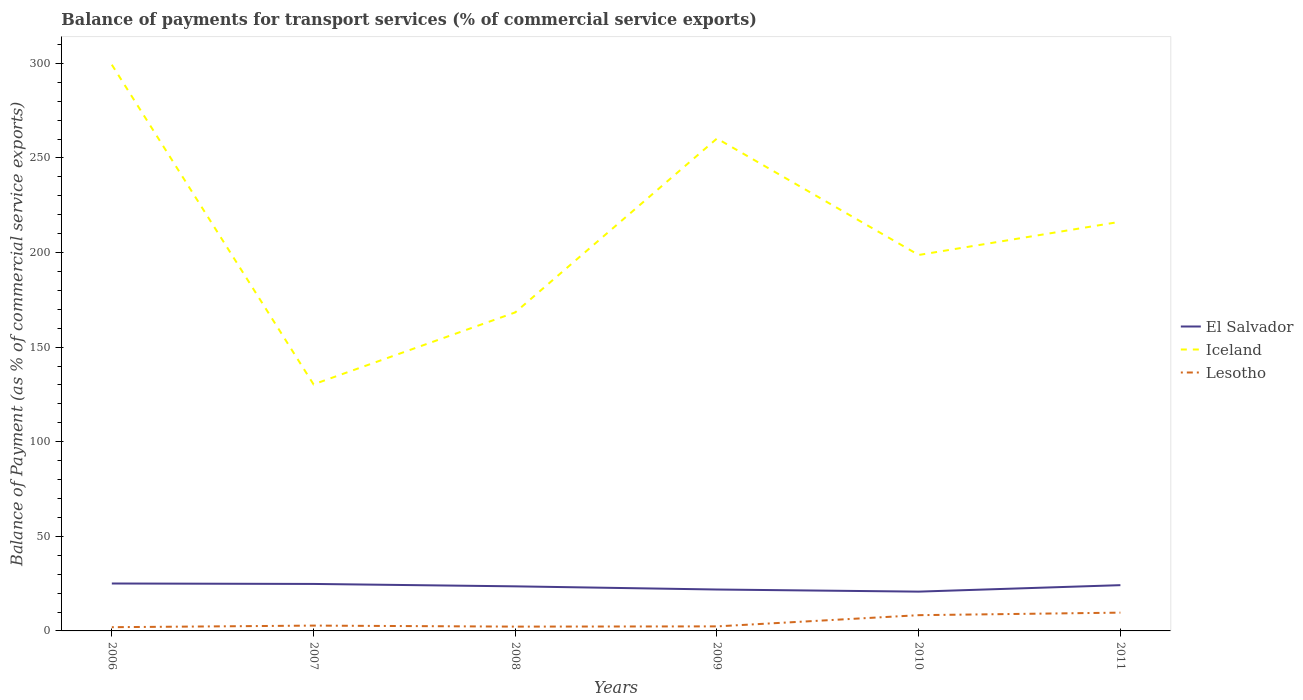Does the line corresponding to Iceland intersect with the line corresponding to Lesotho?
Make the answer very short. No. Across all years, what is the maximum balance of payments for transport services in Lesotho?
Your answer should be compact. 1.97. In which year was the balance of payments for transport services in Lesotho maximum?
Ensure brevity in your answer.  2006. What is the total balance of payments for transport services in El Salvador in the graph?
Keep it short and to the point. 1.27. What is the difference between the highest and the second highest balance of payments for transport services in El Salvador?
Ensure brevity in your answer.  4.3. What is the difference between the highest and the lowest balance of payments for transport services in El Salvador?
Offer a terse response. 4. What is the difference between two consecutive major ticks on the Y-axis?
Keep it short and to the point. 50. Does the graph contain any zero values?
Give a very brief answer. No. Where does the legend appear in the graph?
Your answer should be compact. Center right. How are the legend labels stacked?
Your response must be concise. Vertical. What is the title of the graph?
Your answer should be compact. Balance of payments for transport services (% of commercial service exports). What is the label or title of the X-axis?
Offer a terse response. Years. What is the label or title of the Y-axis?
Your answer should be compact. Balance of Payment (as % of commercial service exports). What is the Balance of Payment (as % of commercial service exports) of El Salvador in 2006?
Ensure brevity in your answer.  25.07. What is the Balance of Payment (as % of commercial service exports) in Iceland in 2006?
Ensure brevity in your answer.  299.28. What is the Balance of Payment (as % of commercial service exports) of Lesotho in 2006?
Your answer should be compact. 1.97. What is the Balance of Payment (as % of commercial service exports) in El Salvador in 2007?
Offer a very short reply. 24.84. What is the Balance of Payment (as % of commercial service exports) in Iceland in 2007?
Offer a terse response. 130.32. What is the Balance of Payment (as % of commercial service exports) in Lesotho in 2007?
Provide a short and direct response. 2.81. What is the Balance of Payment (as % of commercial service exports) of El Salvador in 2008?
Your response must be concise. 23.56. What is the Balance of Payment (as % of commercial service exports) of Iceland in 2008?
Give a very brief answer. 168.36. What is the Balance of Payment (as % of commercial service exports) of Lesotho in 2008?
Provide a short and direct response. 2.27. What is the Balance of Payment (as % of commercial service exports) of El Salvador in 2009?
Provide a succinct answer. 21.88. What is the Balance of Payment (as % of commercial service exports) of Iceland in 2009?
Your answer should be very brief. 260.27. What is the Balance of Payment (as % of commercial service exports) in Lesotho in 2009?
Your response must be concise. 2.4. What is the Balance of Payment (as % of commercial service exports) of El Salvador in 2010?
Offer a terse response. 20.77. What is the Balance of Payment (as % of commercial service exports) of Iceland in 2010?
Your answer should be very brief. 198.71. What is the Balance of Payment (as % of commercial service exports) in Lesotho in 2010?
Your answer should be very brief. 8.32. What is the Balance of Payment (as % of commercial service exports) in El Salvador in 2011?
Your answer should be very brief. 24.19. What is the Balance of Payment (as % of commercial service exports) in Iceland in 2011?
Offer a terse response. 216.28. What is the Balance of Payment (as % of commercial service exports) in Lesotho in 2011?
Make the answer very short. 9.67. Across all years, what is the maximum Balance of Payment (as % of commercial service exports) of El Salvador?
Ensure brevity in your answer.  25.07. Across all years, what is the maximum Balance of Payment (as % of commercial service exports) of Iceland?
Make the answer very short. 299.28. Across all years, what is the maximum Balance of Payment (as % of commercial service exports) of Lesotho?
Keep it short and to the point. 9.67. Across all years, what is the minimum Balance of Payment (as % of commercial service exports) in El Salvador?
Make the answer very short. 20.77. Across all years, what is the minimum Balance of Payment (as % of commercial service exports) of Iceland?
Your answer should be compact. 130.32. Across all years, what is the minimum Balance of Payment (as % of commercial service exports) of Lesotho?
Make the answer very short. 1.97. What is the total Balance of Payment (as % of commercial service exports) of El Salvador in the graph?
Your answer should be very brief. 140.31. What is the total Balance of Payment (as % of commercial service exports) in Iceland in the graph?
Give a very brief answer. 1273.22. What is the total Balance of Payment (as % of commercial service exports) in Lesotho in the graph?
Provide a short and direct response. 27.45. What is the difference between the Balance of Payment (as % of commercial service exports) of El Salvador in 2006 and that in 2007?
Offer a terse response. 0.23. What is the difference between the Balance of Payment (as % of commercial service exports) of Iceland in 2006 and that in 2007?
Ensure brevity in your answer.  168.95. What is the difference between the Balance of Payment (as % of commercial service exports) in Lesotho in 2006 and that in 2007?
Provide a short and direct response. -0.84. What is the difference between the Balance of Payment (as % of commercial service exports) of El Salvador in 2006 and that in 2008?
Offer a very short reply. 1.51. What is the difference between the Balance of Payment (as % of commercial service exports) of Iceland in 2006 and that in 2008?
Offer a terse response. 130.92. What is the difference between the Balance of Payment (as % of commercial service exports) in Lesotho in 2006 and that in 2008?
Your response must be concise. -0.31. What is the difference between the Balance of Payment (as % of commercial service exports) in El Salvador in 2006 and that in 2009?
Your response must be concise. 3.18. What is the difference between the Balance of Payment (as % of commercial service exports) of Iceland in 2006 and that in 2009?
Provide a short and direct response. 39.01. What is the difference between the Balance of Payment (as % of commercial service exports) in Lesotho in 2006 and that in 2009?
Provide a short and direct response. -0.43. What is the difference between the Balance of Payment (as % of commercial service exports) of El Salvador in 2006 and that in 2010?
Make the answer very short. 4.3. What is the difference between the Balance of Payment (as % of commercial service exports) in Iceland in 2006 and that in 2010?
Keep it short and to the point. 100.57. What is the difference between the Balance of Payment (as % of commercial service exports) in Lesotho in 2006 and that in 2010?
Provide a short and direct response. -6.35. What is the difference between the Balance of Payment (as % of commercial service exports) of El Salvador in 2006 and that in 2011?
Ensure brevity in your answer.  0.88. What is the difference between the Balance of Payment (as % of commercial service exports) of Iceland in 2006 and that in 2011?
Your response must be concise. 83. What is the difference between the Balance of Payment (as % of commercial service exports) of Lesotho in 2006 and that in 2011?
Your response must be concise. -7.7. What is the difference between the Balance of Payment (as % of commercial service exports) of El Salvador in 2007 and that in 2008?
Ensure brevity in your answer.  1.27. What is the difference between the Balance of Payment (as % of commercial service exports) of Iceland in 2007 and that in 2008?
Your answer should be very brief. -38.04. What is the difference between the Balance of Payment (as % of commercial service exports) of Lesotho in 2007 and that in 2008?
Keep it short and to the point. 0.54. What is the difference between the Balance of Payment (as % of commercial service exports) of El Salvador in 2007 and that in 2009?
Your answer should be compact. 2.95. What is the difference between the Balance of Payment (as % of commercial service exports) in Iceland in 2007 and that in 2009?
Make the answer very short. -129.95. What is the difference between the Balance of Payment (as % of commercial service exports) in Lesotho in 2007 and that in 2009?
Give a very brief answer. 0.41. What is the difference between the Balance of Payment (as % of commercial service exports) in El Salvador in 2007 and that in 2010?
Offer a very short reply. 4.07. What is the difference between the Balance of Payment (as % of commercial service exports) of Iceland in 2007 and that in 2010?
Your answer should be very brief. -68.38. What is the difference between the Balance of Payment (as % of commercial service exports) in Lesotho in 2007 and that in 2010?
Your answer should be very brief. -5.51. What is the difference between the Balance of Payment (as % of commercial service exports) of El Salvador in 2007 and that in 2011?
Your answer should be very brief. 0.65. What is the difference between the Balance of Payment (as % of commercial service exports) in Iceland in 2007 and that in 2011?
Ensure brevity in your answer.  -85.96. What is the difference between the Balance of Payment (as % of commercial service exports) in Lesotho in 2007 and that in 2011?
Keep it short and to the point. -6.85. What is the difference between the Balance of Payment (as % of commercial service exports) in El Salvador in 2008 and that in 2009?
Provide a succinct answer. 1.68. What is the difference between the Balance of Payment (as % of commercial service exports) of Iceland in 2008 and that in 2009?
Offer a very short reply. -91.91. What is the difference between the Balance of Payment (as % of commercial service exports) of Lesotho in 2008 and that in 2009?
Your answer should be very brief. -0.13. What is the difference between the Balance of Payment (as % of commercial service exports) of El Salvador in 2008 and that in 2010?
Keep it short and to the point. 2.79. What is the difference between the Balance of Payment (as % of commercial service exports) in Iceland in 2008 and that in 2010?
Your response must be concise. -30.35. What is the difference between the Balance of Payment (as % of commercial service exports) in Lesotho in 2008 and that in 2010?
Make the answer very short. -6.05. What is the difference between the Balance of Payment (as % of commercial service exports) in El Salvador in 2008 and that in 2011?
Offer a terse response. -0.63. What is the difference between the Balance of Payment (as % of commercial service exports) in Iceland in 2008 and that in 2011?
Ensure brevity in your answer.  -47.92. What is the difference between the Balance of Payment (as % of commercial service exports) of Lesotho in 2008 and that in 2011?
Make the answer very short. -7.39. What is the difference between the Balance of Payment (as % of commercial service exports) of El Salvador in 2009 and that in 2010?
Make the answer very short. 1.12. What is the difference between the Balance of Payment (as % of commercial service exports) of Iceland in 2009 and that in 2010?
Ensure brevity in your answer.  61.56. What is the difference between the Balance of Payment (as % of commercial service exports) of Lesotho in 2009 and that in 2010?
Make the answer very short. -5.92. What is the difference between the Balance of Payment (as % of commercial service exports) of El Salvador in 2009 and that in 2011?
Offer a very short reply. -2.31. What is the difference between the Balance of Payment (as % of commercial service exports) of Iceland in 2009 and that in 2011?
Provide a succinct answer. 43.99. What is the difference between the Balance of Payment (as % of commercial service exports) of Lesotho in 2009 and that in 2011?
Your response must be concise. -7.26. What is the difference between the Balance of Payment (as % of commercial service exports) of El Salvador in 2010 and that in 2011?
Provide a succinct answer. -3.42. What is the difference between the Balance of Payment (as % of commercial service exports) of Iceland in 2010 and that in 2011?
Ensure brevity in your answer.  -17.57. What is the difference between the Balance of Payment (as % of commercial service exports) of Lesotho in 2010 and that in 2011?
Ensure brevity in your answer.  -1.34. What is the difference between the Balance of Payment (as % of commercial service exports) of El Salvador in 2006 and the Balance of Payment (as % of commercial service exports) of Iceland in 2007?
Your answer should be compact. -105.25. What is the difference between the Balance of Payment (as % of commercial service exports) of El Salvador in 2006 and the Balance of Payment (as % of commercial service exports) of Lesotho in 2007?
Your answer should be very brief. 22.26. What is the difference between the Balance of Payment (as % of commercial service exports) in Iceland in 2006 and the Balance of Payment (as % of commercial service exports) in Lesotho in 2007?
Offer a terse response. 296.46. What is the difference between the Balance of Payment (as % of commercial service exports) of El Salvador in 2006 and the Balance of Payment (as % of commercial service exports) of Iceland in 2008?
Make the answer very short. -143.29. What is the difference between the Balance of Payment (as % of commercial service exports) of El Salvador in 2006 and the Balance of Payment (as % of commercial service exports) of Lesotho in 2008?
Keep it short and to the point. 22.79. What is the difference between the Balance of Payment (as % of commercial service exports) in Iceland in 2006 and the Balance of Payment (as % of commercial service exports) in Lesotho in 2008?
Keep it short and to the point. 297. What is the difference between the Balance of Payment (as % of commercial service exports) in El Salvador in 2006 and the Balance of Payment (as % of commercial service exports) in Iceland in 2009?
Your response must be concise. -235.2. What is the difference between the Balance of Payment (as % of commercial service exports) in El Salvador in 2006 and the Balance of Payment (as % of commercial service exports) in Lesotho in 2009?
Your answer should be compact. 22.67. What is the difference between the Balance of Payment (as % of commercial service exports) of Iceland in 2006 and the Balance of Payment (as % of commercial service exports) of Lesotho in 2009?
Offer a terse response. 296.87. What is the difference between the Balance of Payment (as % of commercial service exports) of El Salvador in 2006 and the Balance of Payment (as % of commercial service exports) of Iceland in 2010?
Offer a terse response. -173.64. What is the difference between the Balance of Payment (as % of commercial service exports) of El Salvador in 2006 and the Balance of Payment (as % of commercial service exports) of Lesotho in 2010?
Provide a succinct answer. 16.75. What is the difference between the Balance of Payment (as % of commercial service exports) in Iceland in 2006 and the Balance of Payment (as % of commercial service exports) in Lesotho in 2010?
Provide a short and direct response. 290.95. What is the difference between the Balance of Payment (as % of commercial service exports) in El Salvador in 2006 and the Balance of Payment (as % of commercial service exports) in Iceland in 2011?
Offer a terse response. -191.21. What is the difference between the Balance of Payment (as % of commercial service exports) in El Salvador in 2006 and the Balance of Payment (as % of commercial service exports) in Lesotho in 2011?
Your answer should be compact. 15.4. What is the difference between the Balance of Payment (as % of commercial service exports) in Iceland in 2006 and the Balance of Payment (as % of commercial service exports) in Lesotho in 2011?
Give a very brief answer. 289.61. What is the difference between the Balance of Payment (as % of commercial service exports) in El Salvador in 2007 and the Balance of Payment (as % of commercial service exports) in Iceland in 2008?
Keep it short and to the point. -143.52. What is the difference between the Balance of Payment (as % of commercial service exports) in El Salvador in 2007 and the Balance of Payment (as % of commercial service exports) in Lesotho in 2008?
Provide a succinct answer. 22.56. What is the difference between the Balance of Payment (as % of commercial service exports) of Iceland in 2007 and the Balance of Payment (as % of commercial service exports) of Lesotho in 2008?
Make the answer very short. 128.05. What is the difference between the Balance of Payment (as % of commercial service exports) of El Salvador in 2007 and the Balance of Payment (as % of commercial service exports) of Iceland in 2009?
Offer a terse response. -235.43. What is the difference between the Balance of Payment (as % of commercial service exports) in El Salvador in 2007 and the Balance of Payment (as % of commercial service exports) in Lesotho in 2009?
Your answer should be compact. 22.43. What is the difference between the Balance of Payment (as % of commercial service exports) of Iceland in 2007 and the Balance of Payment (as % of commercial service exports) of Lesotho in 2009?
Offer a very short reply. 127.92. What is the difference between the Balance of Payment (as % of commercial service exports) in El Salvador in 2007 and the Balance of Payment (as % of commercial service exports) in Iceland in 2010?
Give a very brief answer. -173.87. What is the difference between the Balance of Payment (as % of commercial service exports) in El Salvador in 2007 and the Balance of Payment (as % of commercial service exports) in Lesotho in 2010?
Offer a terse response. 16.51. What is the difference between the Balance of Payment (as % of commercial service exports) of Iceland in 2007 and the Balance of Payment (as % of commercial service exports) of Lesotho in 2010?
Provide a short and direct response. 122. What is the difference between the Balance of Payment (as % of commercial service exports) in El Salvador in 2007 and the Balance of Payment (as % of commercial service exports) in Iceland in 2011?
Your answer should be very brief. -191.44. What is the difference between the Balance of Payment (as % of commercial service exports) of El Salvador in 2007 and the Balance of Payment (as % of commercial service exports) of Lesotho in 2011?
Provide a succinct answer. 15.17. What is the difference between the Balance of Payment (as % of commercial service exports) of Iceland in 2007 and the Balance of Payment (as % of commercial service exports) of Lesotho in 2011?
Give a very brief answer. 120.66. What is the difference between the Balance of Payment (as % of commercial service exports) of El Salvador in 2008 and the Balance of Payment (as % of commercial service exports) of Iceland in 2009?
Offer a very short reply. -236.71. What is the difference between the Balance of Payment (as % of commercial service exports) of El Salvador in 2008 and the Balance of Payment (as % of commercial service exports) of Lesotho in 2009?
Make the answer very short. 21.16. What is the difference between the Balance of Payment (as % of commercial service exports) in Iceland in 2008 and the Balance of Payment (as % of commercial service exports) in Lesotho in 2009?
Your answer should be compact. 165.96. What is the difference between the Balance of Payment (as % of commercial service exports) of El Salvador in 2008 and the Balance of Payment (as % of commercial service exports) of Iceland in 2010?
Your answer should be very brief. -175.15. What is the difference between the Balance of Payment (as % of commercial service exports) in El Salvador in 2008 and the Balance of Payment (as % of commercial service exports) in Lesotho in 2010?
Provide a short and direct response. 15.24. What is the difference between the Balance of Payment (as % of commercial service exports) in Iceland in 2008 and the Balance of Payment (as % of commercial service exports) in Lesotho in 2010?
Make the answer very short. 160.04. What is the difference between the Balance of Payment (as % of commercial service exports) of El Salvador in 2008 and the Balance of Payment (as % of commercial service exports) of Iceland in 2011?
Keep it short and to the point. -192.72. What is the difference between the Balance of Payment (as % of commercial service exports) of El Salvador in 2008 and the Balance of Payment (as % of commercial service exports) of Lesotho in 2011?
Offer a very short reply. 13.9. What is the difference between the Balance of Payment (as % of commercial service exports) in Iceland in 2008 and the Balance of Payment (as % of commercial service exports) in Lesotho in 2011?
Offer a terse response. 158.7. What is the difference between the Balance of Payment (as % of commercial service exports) in El Salvador in 2009 and the Balance of Payment (as % of commercial service exports) in Iceland in 2010?
Offer a very short reply. -176.82. What is the difference between the Balance of Payment (as % of commercial service exports) in El Salvador in 2009 and the Balance of Payment (as % of commercial service exports) in Lesotho in 2010?
Give a very brief answer. 13.56. What is the difference between the Balance of Payment (as % of commercial service exports) of Iceland in 2009 and the Balance of Payment (as % of commercial service exports) of Lesotho in 2010?
Provide a succinct answer. 251.95. What is the difference between the Balance of Payment (as % of commercial service exports) of El Salvador in 2009 and the Balance of Payment (as % of commercial service exports) of Iceland in 2011?
Your answer should be compact. -194.4. What is the difference between the Balance of Payment (as % of commercial service exports) in El Salvador in 2009 and the Balance of Payment (as % of commercial service exports) in Lesotho in 2011?
Provide a short and direct response. 12.22. What is the difference between the Balance of Payment (as % of commercial service exports) of Iceland in 2009 and the Balance of Payment (as % of commercial service exports) of Lesotho in 2011?
Ensure brevity in your answer.  250.6. What is the difference between the Balance of Payment (as % of commercial service exports) of El Salvador in 2010 and the Balance of Payment (as % of commercial service exports) of Iceland in 2011?
Make the answer very short. -195.51. What is the difference between the Balance of Payment (as % of commercial service exports) of El Salvador in 2010 and the Balance of Payment (as % of commercial service exports) of Lesotho in 2011?
Your response must be concise. 11.1. What is the difference between the Balance of Payment (as % of commercial service exports) of Iceland in 2010 and the Balance of Payment (as % of commercial service exports) of Lesotho in 2011?
Make the answer very short. 189.04. What is the average Balance of Payment (as % of commercial service exports) in El Salvador per year?
Give a very brief answer. 23.38. What is the average Balance of Payment (as % of commercial service exports) of Iceland per year?
Your answer should be very brief. 212.2. What is the average Balance of Payment (as % of commercial service exports) of Lesotho per year?
Ensure brevity in your answer.  4.57. In the year 2006, what is the difference between the Balance of Payment (as % of commercial service exports) in El Salvador and Balance of Payment (as % of commercial service exports) in Iceland?
Provide a succinct answer. -274.21. In the year 2006, what is the difference between the Balance of Payment (as % of commercial service exports) in El Salvador and Balance of Payment (as % of commercial service exports) in Lesotho?
Keep it short and to the point. 23.1. In the year 2006, what is the difference between the Balance of Payment (as % of commercial service exports) in Iceland and Balance of Payment (as % of commercial service exports) in Lesotho?
Ensure brevity in your answer.  297.31. In the year 2007, what is the difference between the Balance of Payment (as % of commercial service exports) of El Salvador and Balance of Payment (as % of commercial service exports) of Iceland?
Provide a short and direct response. -105.49. In the year 2007, what is the difference between the Balance of Payment (as % of commercial service exports) of El Salvador and Balance of Payment (as % of commercial service exports) of Lesotho?
Make the answer very short. 22.02. In the year 2007, what is the difference between the Balance of Payment (as % of commercial service exports) in Iceland and Balance of Payment (as % of commercial service exports) in Lesotho?
Your answer should be very brief. 127.51. In the year 2008, what is the difference between the Balance of Payment (as % of commercial service exports) of El Salvador and Balance of Payment (as % of commercial service exports) of Iceland?
Your answer should be very brief. -144.8. In the year 2008, what is the difference between the Balance of Payment (as % of commercial service exports) of El Salvador and Balance of Payment (as % of commercial service exports) of Lesotho?
Ensure brevity in your answer.  21.29. In the year 2008, what is the difference between the Balance of Payment (as % of commercial service exports) in Iceland and Balance of Payment (as % of commercial service exports) in Lesotho?
Keep it short and to the point. 166.09. In the year 2009, what is the difference between the Balance of Payment (as % of commercial service exports) of El Salvador and Balance of Payment (as % of commercial service exports) of Iceland?
Your answer should be compact. -238.38. In the year 2009, what is the difference between the Balance of Payment (as % of commercial service exports) of El Salvador and Balance of Payment (as % of commercial service exports) of Lesotho?
Your response must be concise. 19.48. In the year 2009, what is the difference between the Balance of Payment (as % of commercial service exports) of Iceland and Balance of Payment (as % of commercial service exports) of Lesotho?
Your answer should be compact. 257.87. In the year 2010, what is the difference between the Balance of Payment (as % of commercial service exports) in El Salvador and Balance of Payment (as % of commercial service exports) in Iceland?
Provide a short and direct response. -177.94. In the year 2010, what is the difference between the Balance of Payment (as % of commercial service exports) in El Salvador and Balance of Payment (as % of commercial service exports) in Lesotho?
Offer a terse response. 12.45. In the year 2010, what is the difference between the Balance of Payment (as % of commercial service exports) of Iceland and Balance of Payment (as % of commercial service exports) of Lesotho?
Ensure brevity in your answer.  190.39. In the year 2011, what is the difference between the Balance of Payment (as % of commercial service exports) in El Salvador and Balance of Payment (as % of commercial service exports) in Iceland?
Offer a terse response. -192.09. In the year 2011, what is the difference between the Balance of Payment (as % of commercial service exports) of El Salvador and Balance of Payment (as % of commercial service exports) of Lesotho?
Your answer should be very brief. 14.53. In the year 2011, what is the difference between the Balance of Payment (as % of commercial service exports) of Iceland and Balance of Payment (as % of commercial service exports) of Lesotho?
Your answer should be compact. 206.62. What is the ratio of the Balance of Payment (as % of commercial service exports) in El Salvador in 2006 to that in 2007?
Give a very brief answer. 1.01. What is the ratio of the Balance of Payment (as % of commercial service exports) of Iceland in 2006 to that in 2007?
Your answer should be compact. 2.3. What is the ratio of the Balance of Payment (as % of commercial service exports) in Lesotho in 2006 to that in 2007?
Ensure brevity in your answer.  0.7. What is the ratio of the Balance of Payment (as % of commercial service exports) in El Salvador in 2006 to that in 2008?
Make the answer very short. 1.06. What is the ratio of the Balance of Payment (as % of commercial service exports) of Iceland in 2006 to that in 2008?
Offer a terse response. 1.78. What is the ratio of the Balance of Payment (as % of commercial service exports) in Lesotho in 2006 to that in 2008?
Offer a very short reply. 0.87. What is the ratio of the Balance of Payment (as % of commercial service exports) in El Salvador in 2006 to that in 2009?
Make the answer very short. 1.15. What is the ratio of the Balance of Payment (as % of commercial service exports) of Iceland in 2006 to that in 2009?
Provide a short and direct response. 1.15. What is the ratio of the Balance of Payment (as % of commercial service exports) of Lesotho in 2006 to that in 2009?
Your response must be concise. 0.82. What is the ratio of the Balance of Payment (as % of commercial service exports) in El Salvador in 2006 to that in 2010?
Provide a short and direct response. 1.21. What is the ratio of the Balance of Payment (as % of commercial service exports) in Iceland in 2006 to that in 2010?
Make the answer very short. 1.51. What is the ratio of the Balance of Payment (as % of commercial service exports) of Lesotho in 2006 to that in 2010?
Ensure brevity in your answer.  0.24. What is the ratio of the Balance of Payment (as % of commercial service exports) in El Salvador in 2006 to that in 2011?
Keep it short and to the point. 1.04. What is the ratio of the Balance of Payment (as % of commercial service exports) of Iceland in 2006 to that in 2011?
Your answer should be very brief. 1.38. What is the ratio of the Balance of Payment (as % of commercial service exports) in Lesotho in 2006 to that in 2011?
Provide a succinct answer. 0.2. What is the ratio of the Balance of Payment (as % of commercial service exports) in El Salvador in 2007 to that in 2008?
Provide a succinct answer. 1.05. What is the ratio of the Balance of Payment (as % of commercial service exports) of Iceland in 2007 to that in 2008?
Make the answer very short. 0.77. What is the ratio of the Balance of Payment (as % of commercial service exports) of Lesotho in 2007 to that in 2008?
Your answer should be very brief. 1.24. What is the ratio of the Balance of Payment (as % of commercial service exports) of El Salvador in 2007 to that in 2009?
Give a very brief answer. 1.13. What is the ratio of the Balance of Payment (as % of commercial service exports) in Iceland in 2007 to that in 2009?
Your answer should be very brief. 0.5. What is the ratio of the Balance of Payment (as % of commercial service exports) of Lesotho in 2007 to that in 2009?
Provide a succinct answer. 1.17. What is the ratio of the Balance of Payment (as % of commercial service exports) in El Salvador in 2007 to that in 2010?
Provide a short and direct response. 1.2. What is the ratio of the Balance of Payment (as % of commercial service exports) in Iceland in 2007 to that in 2010?
Your answer should be very brief. 0.66. What is the ratio of the Balance of Payment (as % of commercial service exports) of Lesotho in 2007 to that in 2010?
Your response must be concise. 0.34. What is the ratio of the Balance of Payment (as % of commercial service exports) in El Salvador in 2007 to that in 2011?
Provide a succinct answer. 1.03. What is the ratio of the Balance of Payment (as % of commercial service exports) in Iceland in 2007 to that in 2011?
Your answer should be very brief. 0.6. What is the ratio of the Balance of Payment (as % of commercial service exports) in Lesotho in 2007 to that in 2011?
Ensure brevity in your answer.  0.29. What is the ratio of the Balance of Payment (as % of commercial service exports) of El Salvador in 2008 to that in 2009?
Make the answer very short. 1.08. What is the ratio of the Balance of Payment (as % of commercial service exports) in Iceland in 2008 to that in 2009?
Provide a succinct answer. 0.65. What is the ratio of the Balance of Payment (as % of commercial service exports) in Lesotho in 2008 to that in 2009?
Your answer should be very brief. 0.95. What is the ratio of the Balance of Payment (as % of commercial service exports) of El Salvador in 2008 to that in 2010?
Keep it short and to the point. 1.13. What is the ratio of the Balance of Payment (as % of commercial service exports) in Iceland in 2008 to that in 2010?
Keep it short and to the point. 0.85. What is the ratio of the Balance of Payment (as % of commercial service exports) of Lesotho in 2008 to that in 2010?
Give a very brief answer. 0.27. What is the ratio of the Balance of Payment (as % of commercial service exports) of Iceland in 2008 to that in 2011?
Keep it short and to the point. 0.78. What is the ratio of the Balance of Payment (as % of commercial service exports) in Lesotho in 2008 to that in 2011?
Ensure brevity in your answer.  0.24. What is the ratio of the Balance of Payment (as % of commercial service exports) of El Salvador in 2009 to that in 2010?
Provide a short and direct response. 1.05. What is the ratio of the Balance of Payment (as % of commercial service exports) in Iceland in 2009 to that in 2010?
Offer a very short reply. 1.31. What is the ratio of the Balance of Payment (as % of commercial service exports) of Lesotho in 2009 to that in 2010?
Your answer should be compact. 0.29. What is the ratio of the Balance of Payment (as % of commercial service exports) of El Salvador in 2009 to that in 2011?
Offer a very short reply. 0.9. What is the ratio of the Balance of Payment (as % of commercial service exports) in Iceland in 2009 to that in 2011?
Give a very brief answer. 1.2. What is the ratio of the Balance of Payment (as % of commercial service exports) of Lesotho in 2009 to that in 2011?
Give a very brief answer. 0.25. What is the ratio of the Balance of Payment (as % of commercial service exports) in El Salvador in 2010 to that in 2011?
Your answer should be compact. 0.86. What is the ratio of the Balance of Payment (as % of commercial service exports) of Iceland in 2010 to that in 2011?
Offer a terse response. 0.92. What is the ratio of the Balance of Payment (as % of commercial service exports) in Lesotho in 2010 to that in 2011?
Provide a short and direct response. 0.86. What is the difference between the highest and the second highest Balance of Payment (as % of commercial service exports) of El Salvador?
Provide a succinct answer. 0.23. What is the difference between the highest and the second highest Balance of Payment (as % of commercial service exports) in Iceland?
Provide a short and direct response. 39.01. What is the difference between the highest and the second highest Balance of Payment (as % of commercial service exports) of Lesotho?
Provide a succinct answer. 1.34. What is the difference between the highest and the lowest Balance of Payment (as % of commercial service exports) of El Salvador?
Provide a short and direct response. 4.3. What is the difference between the highest and the lowest Balance of Payment (as % of commercial service exports) of Iceland?
Keep it short and to the point. 168.95. What is the difference between the highest and the lowest Balance of Payment (as % of commercial service exports) in Lesotho?
Offer a terse response. 7.7. 